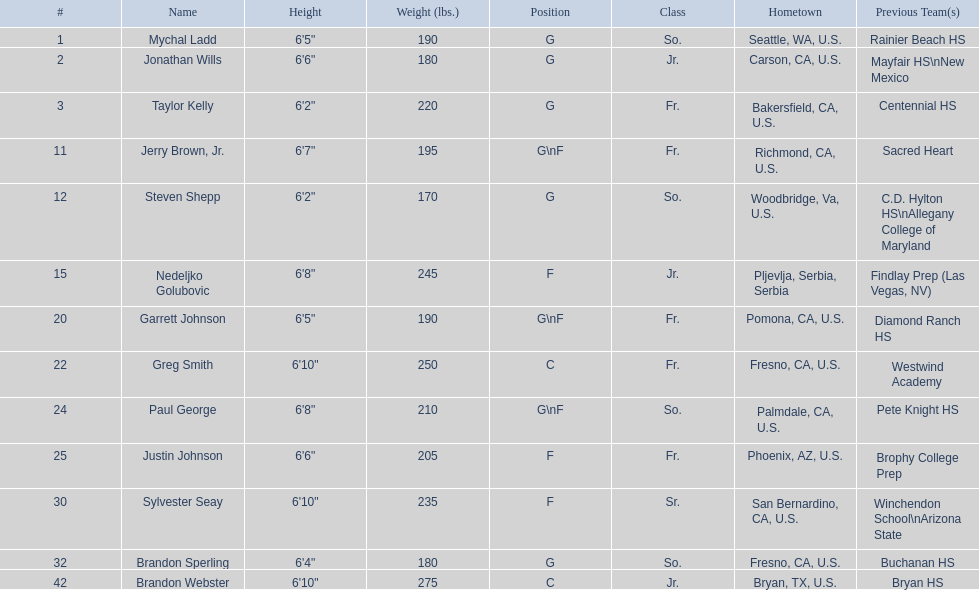Who participated in the 2009-10 fresno state bulldogs men's basketball squad? Mychal Ladd, Jonathan Wills, Taylor Kelly, Jerry Brown, Jr., Steven Shepp, Nedeljko Golubovic, Garrett Johnson, Greg Smith, Paul George, Justin Johnson, Sylvester Seay, Brandon Sperling, Brandon Webster. What was each player's role? G, G, G, G\nF, G, F, G\nF, C, G\nF, F, F, G, C. And what was their height? 6'5", 6'6", 6'2", 6'7", 6'2", 6'8", 6'5", 6'10", 6'8", 6'6", 6'10", 6'4", 6'10". Among these players, who was the shortest forward? Justin Johnson. 